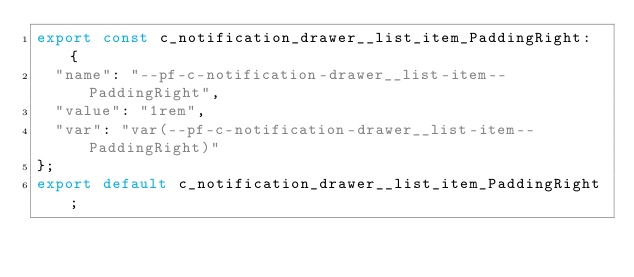Convert code to text. <code><loc_0><loc_0><loc_500><loc_500><_TypeScript_>export const c_notification_drawer__list_item_PaddingRight: {
  "name": "--pf-c-notification-drawer__list-item--PaddingRight",
  "value": "1rem",
  "var": "var(--pf-c-notification-drawer__list-item--PaddingRight)"
};
export default c_notification_drawer__list_item_PaddingRight;</code> 